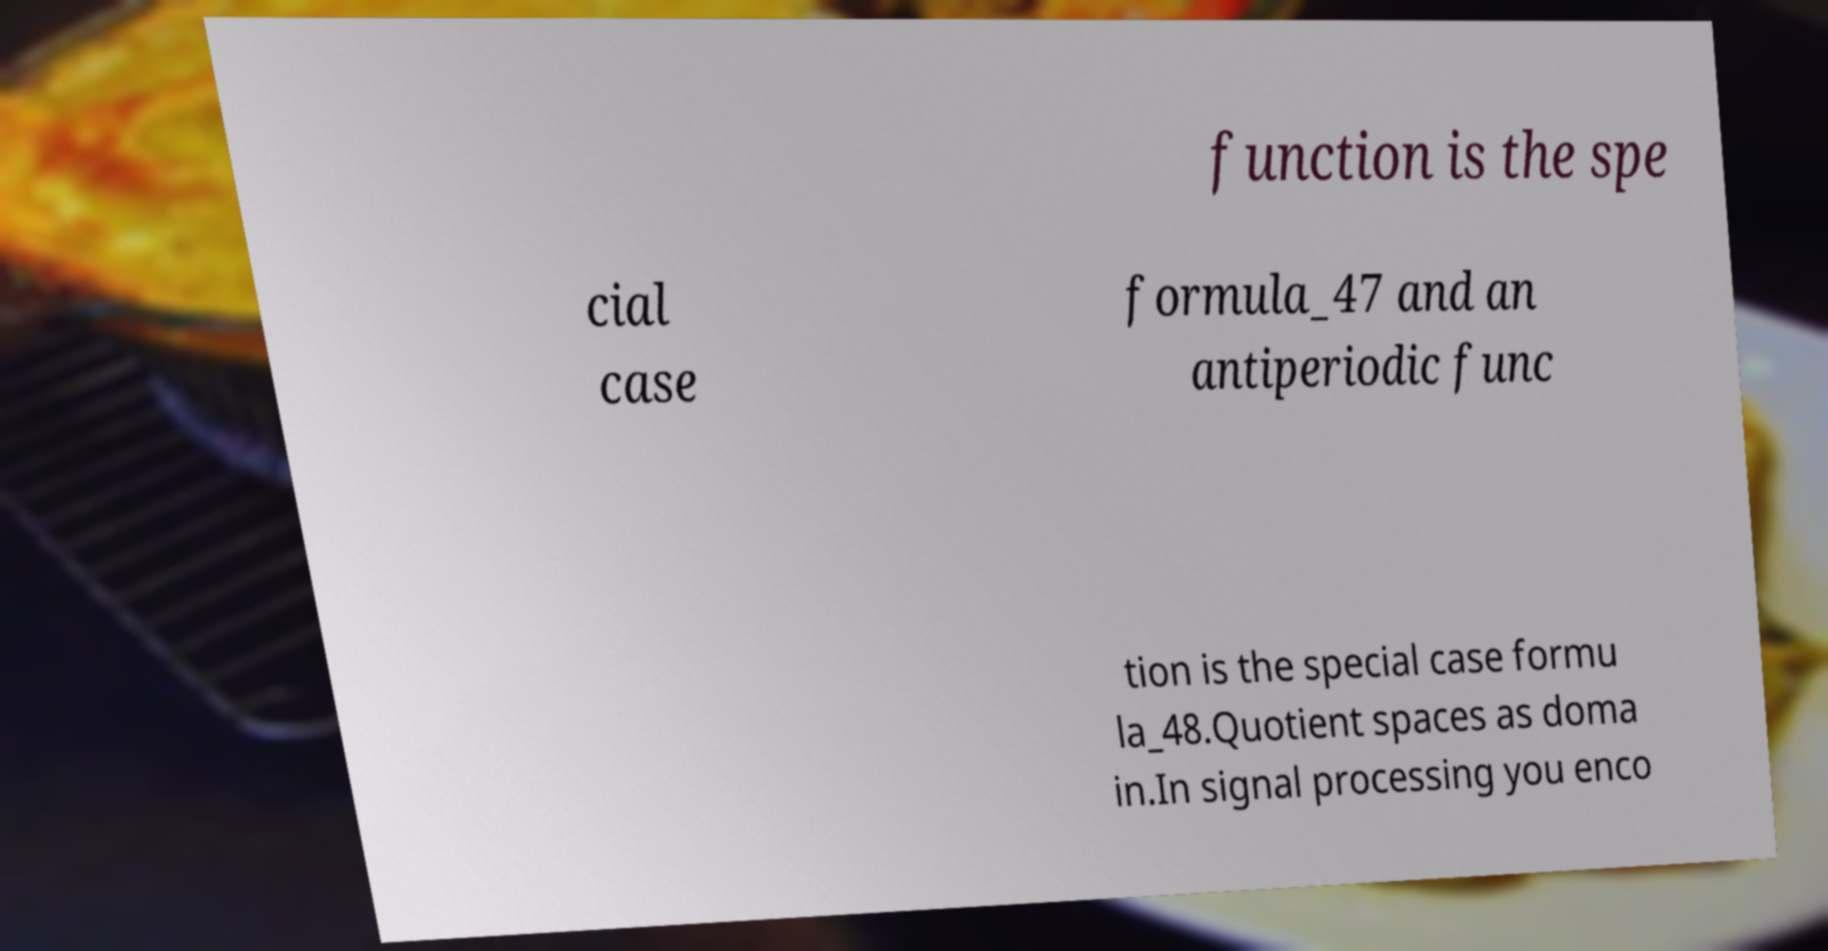There's text embedded in this image that I need extracted. Can you transcribe it verbatim? function is the spe cial case formula_47 and an antiperiodic func tion is the special case formu la_48.Quotient spaces as doma in.In signal processing you enco 